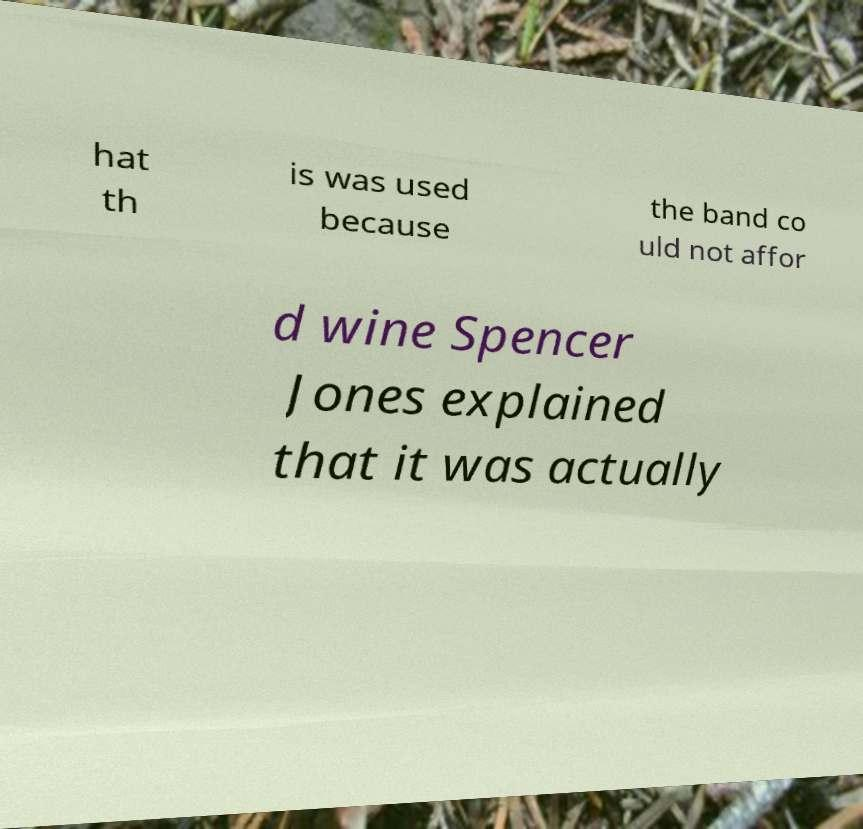Could you extract and type out the text from this image? hat th is was used because the band co uld not affor d wine Spencer Jones explained that it was actually 